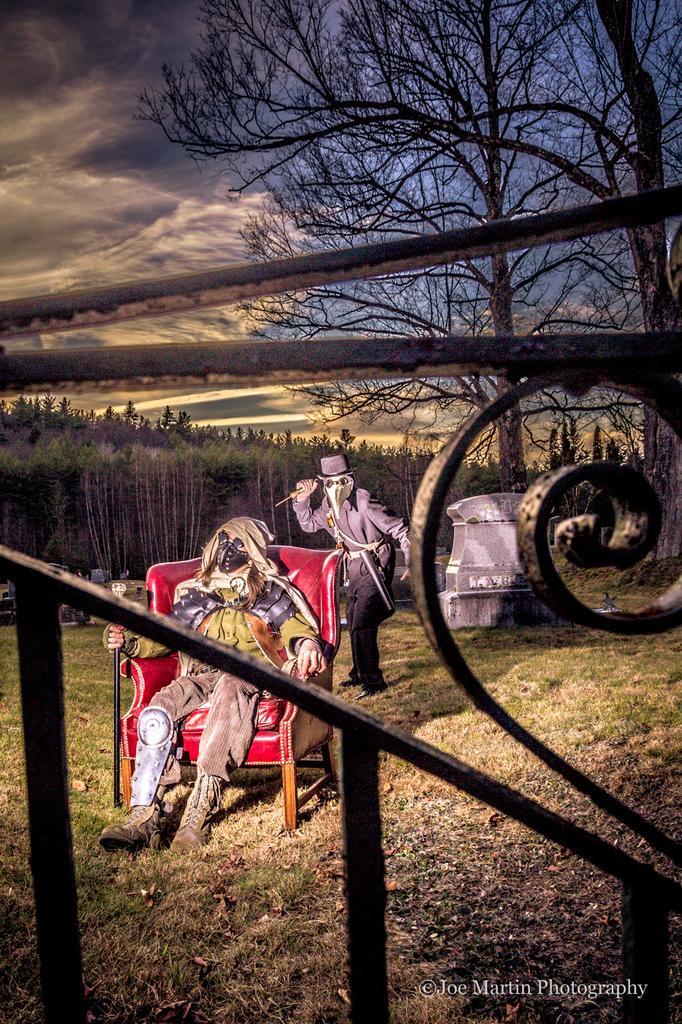Please provide a concise description of this image. In this image I can see the railing. To the side I can see two people with different costumes. One person is sitting on the red color chair. In the background there are many trees, clouds and the sky. 